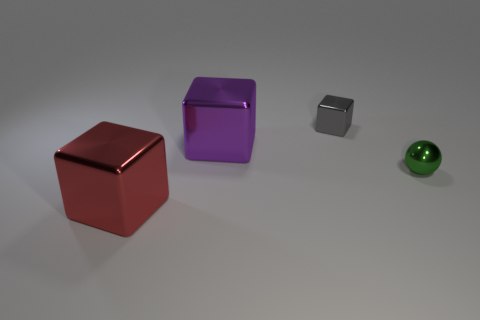What number of other things are there of the same size as the green sphere?
Provide a succinct answer. 1. Is the size of the ball in front of the tiny gray cube the same as the shiny thing that is in front of the green sphere?
Your answer should be compact. No. How many things are small blue metal cubes or large objects that are to the left of the large purple metallic block?
Provide a succinct answer. 1. There is a object that is in front of the metal sphere; how big is it?
Provide a succinct answer. Large. Is the number of large purple metal objects that are to the right of the tiny shiny ball less than the number of big red shiny things to the left of the red metal cube?
Provide a short and direct response. No. What is the material of the object that is both in front of the large purple shiny object and to the left of the gray cube?
Give a very brief answer. Metal. There is a large shiny thing behind the thing that is in front of the small green thing; what is its shape?
Your response must be concise. Cube. Is the color of the metal ball the same as the small metal cube?
Make the answer very short. No. How many cyan things are either shiny balls or tiny objects?
Give a very brief answer. 0. Are there any tiny gray cubes in front of the small green metallic object?
Keep it short and to the point. No. 